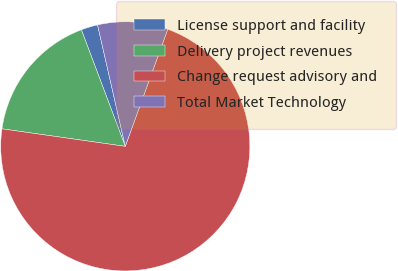Convert chart. <chart><loc_0><loc_0><loc_500><loc_500><pie_chart><fcel>License support and facility<fcel>Delivery project revenues<fcel>Change request advisory and<fcel>Total Market Technology<nl><fcel>2.16%<fcel>17.02%<fcel>71.71%<fcel>9.11%<nl></chart> 